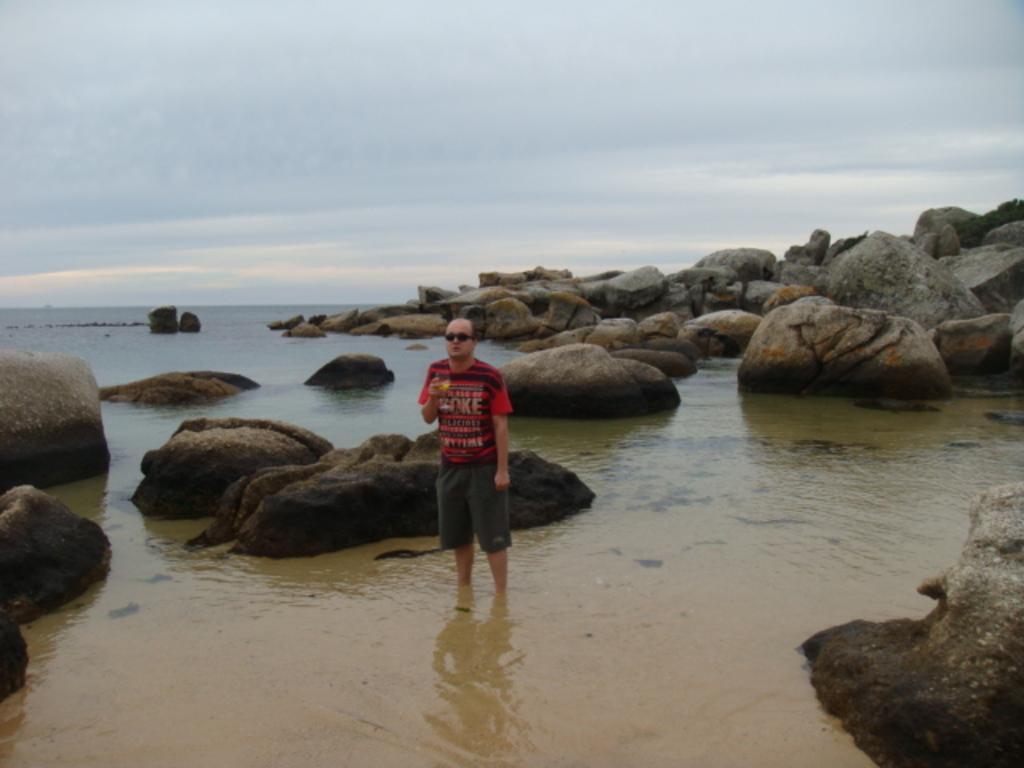Describe this image in one or two sentences. In this image we can see a man is standing in the water. Here we can see rocks. In the background there is sky with clouds. 